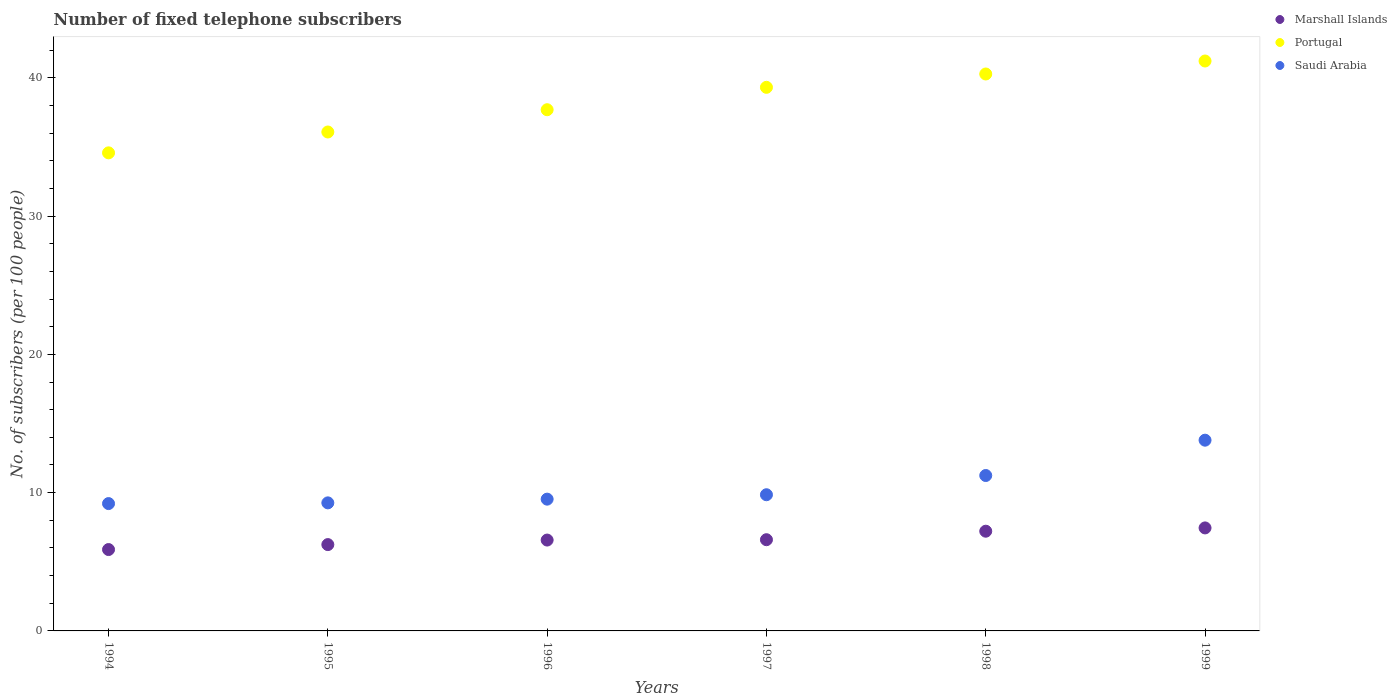What is the number of fixed telephone subscribers in Marshall Islands in 1994?
Give a very brief answer. 5.88. Across all years, what is the maximum number of fixed telephone subscribers in Saudi Arabia?
Your answer should be compact. 13.79. Across all years, what is the minimum number of fixed telephone subscribers in Portugal?
Provide a short and direct response. 34.57. In which year was the number of fixed telephone subscribers in Marshall Islands maximum?
Offer a terse response. 1999. In which year was the number of fixed telephone subscribers in Portugal minimum?
Offer a very short reply. 1994. What is the total number of fixed telephone subscribers in Marshall Islands in the graph?
Ensure brevity in your answer.  39.95. What is the difference between the number of fixed telephone subscribers in Saudi Arabia in 1995 and that in 1998?
Your answer should be very brief. -1.98. What is the difference between the number of fixed telephone subscribers in Saudi Arabia in 1998 and the number of fixed telephone subscribers in Marshall Islands in 1996?
Keep it short and to the point. 4.67. What is the average number of fixed telephone subscribers in Marshall Islands per year?
Provide a short and direct response. 6.66. In the year 1997, what is the difference between the number of fixed telephone subscribers in Saudi Arabia and number of fixed telephone subscribers in Marshall Islands?
Make the answer very short. 3.25. What is the ratio of the number of fixed telephone subscribers in Saudi Arabia in 1994 to that in 1999?
Make the answer very short. 0.67. Is the number of fixed telephone subscribers in Saudi Arabia in 1994 less than that in 1997?
Provide a succinct answer. Yes. What is the difference between the highest and the second highest number of fixed telephone subscribers in Saudi Arabia?
Your answer should be very brief. 2.55. What is the difference between the highest and the lowest number of fixed telephone subscribers in Saudi Arabia?
Your answer should be very brief. 4.58. In how many years, is the number of fixed telephone subscribers in Saudi Arabia greater than the average number of fixed telephone subscribers in Saudi Arabia taken over all years?
Give a very brief answer. 2. Is it the case that in every year, the sum of the number of fixed telephone subscribers in Marshall Islands and number of fixed telephone subscribers in Portugal  is greater than the number of fixed telephone subscribers in Saudi Arabia?
Give a very brief answer. Yes. Does the number of fixed telephone subscribers in Marshall Islands monotonically increase over the years?
Provide a succinct answer. Yes. Is the number of fixed telephone subscribers in Saudi Arabia strictly greater than the number of fixed telephone subscribers in Marshall Islands over the years?
Provide a short and direct response. Yes. Is the number of fixed telephone subscribers in Saudi Arabia strictly less than the number of fixed telephone subscribers in Portugal over the years?
Provide a short and direct response. Yes. What is the difference between two consecutive major ticks on the Y-axis?
Offer a terse response. 10. What is the title of the graph?
Your response must be concise. Number of fixed telephone subscribers. Does "Guinea" appear as one of the legend labels in the graph?
Offer a very short reply. No. What is the label or title of the Y-axis?
Provide a short and direct response. No. of subscribers (per 100 people). What is the No. of subscribers (per 100 people) in Marshall Islands in 1994?
Ensure brevity in your answer.  5.88. What is the No. of subscribers (per 100 people) in Portugal in 1994?
Give a very brief answer. 34.57. What is the No. of subscribers (per 100 people) in Saudi Arabia in 1994?
Provide a succinct answer. 9.21. What is the No. of subscribers (per 100 people) in Marshall Islands in 1995?
Your answer should be very brief. 6.24. What is the No. of subscribers (per 100 people) of Portugal in 1995?
Offer a terse response. 36.08. What is the No. of subscribers (per 100 people) in Saudi Arabia in 1995?
Offer a terse response. 9.26. What is the No. of subscribers (per 100 people) in Marshall Islands in 1996?
Give a very brief answer. 6.57. What is the No. of subscribers (per 100 people) in Portugal in 1996?
Ensure brevity in your answer.  37.69. What is the No. of subscribers (per 100 people) in Saudi Arabia in 1996?
Your response must be concise. 9.53. What is the No. of subscribers (per 100 people) in Marshall Islands in 1997?
Ensure brevity in your answer.  6.6. What is the No. of subscribers (per 100 people) of Portugal in 1997?
Offer a terse response. 39.31. What is the No. of subscribers (per 100 people) in Saudi Arabia in 1997?
Provide a short and direct response. 9.85. What is the No. of subscribers (per 100 people) in Marshall Islands in 1998?
Ensure brevity in your answer.  7.21. What is the No. of subscribers (per 100 people) of Portugal in 1998?
Your answer should be very brief. 40.27. What is the No. of subscribers (per 100 people) in Saudi Arabia in 1998?
Offer a terse response. 11.24. What is the No. of subscribers (per 100 people) of Marshall Islands in 1999?
Ensure brevity in your answer.  7.45. What is the No. of subscribers (per 100 people) of Portugal in 1999?
Keep it short and to the point. 41.21. What is the No. of subscribers (per 100 people) in Saudi Arabia in 1999?
Provide a succinct answer. 13.79. Across all years, what is the maximum No. of subscribers (per 100 people) in Marshall Islands?
Your answer should be compact. 7.45. Across all years, what is the maximum No. of subscribers (per 100 people) in Portugal?
Your answer should be compact. 41.21. Across all years, what is the maximum No. of subscribers (per 100 people) of Saudi Arabia?
Your answer should be compact. 13.79. Across all years, what is the minimum No. of subscribers (per 100 people) in Marshall Islands?
Provide a succinct answer. 5.88. Across all years, what is the minimum No. of subscribers (per 100 people) of Portugal?
Your answer should be compact. 34.57. Across all years, what is the minimum No. of subscribers (per 100 people) of Saudi Arabia?
Give a very brief answer. 9.21. What is the total No. of subscribers (per 100 people) of Marshall Islands in the graph?
Your answer should be compact. 39.95. What is the total No. of subscribers (per 100 people) of Portugal in the graph?
Provide a succinct answer. 229.13. What is the total No. of subscribers (per 100 people) in Saudi Arabia in the graph?
Your response must be concise. 62.88. What is the difference between the No. of subscribers (per 100 people) of Marshall Islands in 1994 and that in 1995?
Offer a terse response. -0.36. What is the difference between the No. of subscribers (per 100 people) of Portugal in 1994 and that in 1995?
Your answer should be very brief. -1.51. What is the difference between the No. of subscribers (per 100 people) of Saudi Arabia in 1994 and that in 1995?
Your answer should be compact. -0.05. What is the difference between the No. of subscribers (per 100 people) of Marshall Islands in 1994 and that in 1996?
Offer a terse response. -0.69. What is the difference between the No. of subscribers (per 100 people) of Portugal in 1994 and that in 1996?
Provide a succinct answer. -3.12. What is the difference between the No. of subscribers (per 100 people) of Saudi Arabia in 1994 and that in 1996?
Offer a very short reply. -0.32. What is the difference between the No. of subscribers (per 100 people) in Marshall Islands in 1994 and that in 1997?
Provide a succinct answer. -0.71. What is the difference between the No. of subscribers (per 100 people) of Portugal in 1994 and that in 1997?
Offer a terse response. -4.74. What is the difference between the No. of subscribers (per 100 people) in Saudi Arabia in 1994 and that in 1997?
Provide a short and direct response. -0.64. What is the difference between the No. of subscribers (per 100 people) of Marshall Islands in 1994 and that in 1998?
Provide a succinct answer. -1.33. What is the difference between the No. of subscribers (per 100 people) in Portugal in 1994 and that in 1998?
Your answer should be compact. -5.7. What is the difference between the No. of subscribers (per 100 people) of Saudi Arabia in 1994 and that in 1998?
Your response must be concise. -2.03. What is the difference between the No. of subscribers (per 100 people) in Marshall Islands in 1994 and that in 1999?
Keep it short and to the point. -1.56. What is the difference between the No. of subscribers (per 100 people) in Portugal in 1994 and that in 1999?
Ensure brevity in your answer.  -6.64. What is the difference between the No. of subscribers (per 100 people) in Saudi Arabia in 1994 and that in 1999?
Give a very brief answer. -4.58. What is the difference between the No. of subscribers (per 100 people) in Marshall Islands in 1995 and that in 1996?
Offer a very short reply. -0.33. What is the difference between the No. of subscribers (per 100 people) in Portugal in 1995 and that in 1996?
Your answer should be compact. -1.61. What is the difference between the No. of subscribers (per 100 people) of Saudi Arabia in 1995 and that in 1996?
Offer a very short reply. -0.27. What is the difference between the No. of subscribers (per 100 people) of Marshall Islands in 1995 and that in 1997?
Give a very brief answer. -0.35. What is the difference between the No. of subscribers (per 100 people) of Portugal in 1995 and that in 1997?
Make the answer very short. -3.23. What is the difference between the No. of subscribers (per 100 people) in Saudi Arabia in 1995 and that in 1997?
Provide a succinct answer. -0.59. What is the difference between the No. of subscribers (per 100 people) of Marshall Islands in 1995 and that in 1998?
Offer a very short reply. -0.97. What is the difference between the No. of subscribers (per 100 people) in Portugal in 1995 and that in 1998?
Give a very brief answer. -4.19. What is the difference between the No. of subscribers (per 100 people) in Saudi Arabia in 1995 and that in 1998?
Provide a succinct answer. -1.98. What is the difference between the No. of subscribers (per 100 people) in Marshall Islands in 1995 and that in 1999?
Offer a terse response. -1.21. What is the difference between the No. of subscribers (per 100 people) in Portugal in 1995 and that in 1999?
Keep it short and to the point. -5.13. What is the difference between the No. of subscribers (per 100 people) in Saudi Arabia in 1995 and that in 1999?
Offer a terse response. -4.53. What is the difference between the No. of subscribers (per 100 people) in Marshall Islands in 1996 and that in 1997?
Give a very brief answer. -0.03. What is the difference between the No. of subscribers (per 100 people) of Portugal in 1996 and that in 1997?
Your response must be concise. -1.62. What is the difference between the No. of subscribers (per 100 people) of Saudi Arabia in 1996 and that in 1997?
Offer a terse response. -0.32. What is the difference between the No. of subscribers (per 100 people) of Marshall Islands in 1996 and that in 1998?
Your answer should be very brief. -0.64. What is the difference between the No. of subscribers (per 100 people) in Portugal in 1996 and that in 1998?
Make the answer very short. -2.58. What is the difference between the No. of subscribers (per 100 people) in Saudi Arabia in 1996 and that in 1998?
Give a very brief answer. -1.71. What is the difference between the No. of subscribers (per 100 people) in Marshall Islands in 1996 and that in 1999?
Your answer should be compact. -0.88. What is the difference between the No. of subscribers (per 100 people) in Portugal in 1996 and that in 1999?
Offer a very short reply. -3.52. What is the difference between the No. of subscribers (per 100 people) in Saudi Arabia in 1996 and that in 1999?
Offer a very short reply. -4.26. What is the difference between the No. of subscribers (per 100 people) of Marshall Islands in 1997 and that in 1998?
Provide a succinct answer. -0.61. What is the difference between the No. of subscribers (per 100 people) in Portugal in 1997 and that in 1998?
Provide a succinct answer. -0.96. What is the difference between the No. of subscribers (per 100 people) of Saudi Arabia in 1997 and that in 1998?
Your answer should be compact. -1.39. What is the difference between the No. of subscribers (per 100 people) in Marshall Islands in 1997 and that in 1999?
Ensure brevity in your answer.  -0.85. What is the difference between the No. of subscribers (per 100 people) in Portugal in 1997 and that in 1999?
Provide a short and direct response. -1.9. What is the difference between the No. of subscribers (per 100 people) in Saudi Arabia in 1997 and that in 1999?
Your response must be concise. -3.94. What is the difference between the No. of subscribers (per 100 people) in Marshall Islands in 1998 and that in 1999?
Your answer should be very brief. -0.24. What is the difference between the No. of subscribers (per 100 people) of Portugal in 1998 and that in 1999?
Make the answer very short. -0.94. What is the difference between the No. of subscribers (per 100 people) of Saudi Arabia in 1998 and that in 1999?
Give a very brief answer. -2.55. What is the difference between the No. of subscribers (per 100 people) of Marshall Islands in 1994 and the No. of subscribers (per 100 people) of Portugal in 1995?
Your answer should be very brief. -30.19. What is the difference between the No. of subscribers (per 100 people) in Marshall Islands in 1994 and the No. of subscribers (per 100 people) in Saudi Arabia in 1995?
Offer a very short reply. -3.38. What is the difference between the No. of subscribers (per 100 people) of Portugal in 1994 and the No. of subscribers (per 100 people) of Saudi Arabia in 1995?
Offer a terse response. 25.31. What is the difference between the No. of subscribers (per 100 people) of Marshall Islands in 1994 and the No. of subscribers (per 100 people) of Portugal in 1996?
Provide a short and direct response. -31.8. What is the difference between the No. of subscribers (per 100 people) of Marshall Islands in 1994 and the No. of subscribers (per 100 people) of Saudi Arabia in 1996?
Make the answer very short. -3.64. What is the difference between the No. of subscribers (per 100 people) in Portugal in 1994 and the No. of subscribers (per 100 people) in Saudi Arabia in 1996?
Ensure brevity in your answer.  25.04. What is the difference between the No. of subscribers (per 100 people) in Marshall Islands in 1994 and the No. of subscribers (per 100 people) in Portugal in 1997?
Your answer should be compact. -33.42. What is the difference between the No. of subscribers (per 100 people) of Marshall Islands in 1994 and the No. of subscribers (per 100 people) of Saudi Arabia in 1997?
Provide a succinct answer. -3.96. What is the difference between the No. of subscribers (per 100 people) in Portugal in 1994 and the No. of subscribers (per 100 people) in Saudi Arabia in 1997?
Provide a short and direct response. 24.72. What is the difference between the No. of subscribers (per 100 people) of Marshall Islands in 1994 and the No. of subscribers (per 100 people) of Portugal in 1998?
Your answer should be very brief. -34.39. What is the difference between the No. of subscribers (per 100 people) in Marshall Islands in 1994 and the No. of subscribers (per 100 people) in Saudi Arabia in 1998?
Your answer should be compact. -5.35. What is the difference between the No. of subscribers (per 100 people) of Portugal in 1994 and the No. of subscribers (per 100 people) of Saudi Arabia in 1998?
Make the answer very short. 23.33. What is the difference between the No. of subscribers (per 100 people) in Marshall Islands in 1994 and the No. of subscribers (per 100 people) in Portugal in 1999?
Make the answer very short. -35.33. What is the difference between the No. of subscribers (per 100 people) in Marshall Islands in 1994 and the No. of subscribers (per 100 people) in Saudi Arabia in 1999?
Provide a short and direct response. -7.91. What is the difference between the No. of subscribers (per 100 people) in Portugal in 1994 and the No. of subscribers (per 100 people) in Saudi Arabia in 1999?
Provide a succinct answer. 20.78. What is the difference between the No. of subscribers (per 100 people) in Marshall Islands in 1995 and the No. of subscribers (per 100 people) in Portugal in 1996?
Make the answer very short. -31.45. What is the difference between the No. of subscribers (per 100 people) in Marshall Islands in 1995 and the No. of subscribers (per 100 people) in Saudi Arabia in 1996?
Your answer should be compact. -3.29. What is the difference between the No. of subscribers (per 100 people) of Portugal in 1995 and the No. of subscribers (per 100 people) of Saudi Arabia in 1996?
Ensure brevity in your answer.  26.55. What is the difference between the No. of subscribers (per 100 people) in Marshall Islands in 1995 and the No. of subscribers (per 100 people) in Portugal in 1997?
Keep it short and to the point. -33.07. What is the difference between the No. of subscribers (per 100 people) of Marshall Islands in 1995 and the No. of subscribers (per 100 people) of Saudi Arabia in 1997?
Ensure brevity in your answer.  -3.6. What is the difference between the No. of subscribers (per 100 people) of Portugal in 1995 and the No. of subscribers (per 100 people) of Saudi Arabia in 1997?
Provide a short and direct response. 26.23. What is the difference between the No. of subscribers (per 100 people) of Marshall Islands in 1995 and the No. of subscribers (per 100 people) of Portugal in 1998?
Keep it short and to the point. -34.03. What is the difference between the No. of subscribers (per 100 people) of Marshall Islands in 1995 and the No. of subscribers (per 100 people) of Saudi Arabia in 1998?
Offer a very short reply. -5. What is the difference between the No. of subscribers (per 100 people) of Portugal in 1995 and the No. of subscribers (per 100 people) of Saudi Arabia in 1998?
Keep it short and to the point. 24.84. What is the difference between the No. of subscribers (per 100 people) of Marshall Islands in 1995 and the No. of subscribers (per 100 people) of Portugal in 1999?
Keep it short and to the point. -34.97. What is the difference between the No. of subscribers (per 100 people) in Marshall Islands in 1995 and the No. of subscribers (per 100 people) in Saudi Arabia in 1999?
Provide a short and direct response. -7.55. What is the difference between the No. of subscribers (per 100 people) of Portugal in 1995 and the No. of subscribers (per 100 people) of Saudi Arabia in 1999?
Ensure brevity in your answer.  22.29. What is the difference between the No. of subscribers (per 100 people) in Marshall Islands in 1996 and the No. of subscribers (per 100 people) in Portugal in 1997?
Make the answer very short. -32.74. What is the difference between the No. of subscribers (per 100 people) in Marshall Islands in 1996 and the No. of subscribers (per 100 people) in Saudi Arabia in 1997?
Your answer should be very brief. -3.28. What is the difference between the No. of subscribers (per 100 people) of Portugal in 1996 and the No. of subscribers (per 100 people) of Saudi Arabia in 1997?
Offer a terse response. 27.84. What is the difference between the No. of subscribers (per 100 people) of Marshall Islands in 1996 and the No. of subscribers (per 100 people) of Portugal in 1998?
Keep it short and to the point. -33.7. What is the difference between the No. of subscribers (per 100 people) in Marshall Islands in 1996 and the No. of subscribers (per 100 people) in Saudi Arabia in 1998?
Give a very brief answer. -4.67. What is the difference between the No. of subscribers (per 100 people) in Portugal in 1996 and the No. of subscribers (per 100 people) in Saudi Arabia in 1998?
Your answer should be very brief. 26.45. What is the difference between the No. of subscribers (per 100 people) of Marshall Islands in 1996 and the No. of subscribers (per 100 people) of Portugal in 1999?
Your answer should be very brief. -34.64. What is the difference between the No. of subscribers (per 100 people) in Marshall Islands in 1996 and the No. of subscribers (per 100 people) in Saudi Arabia in 1999?
Make the answer very short. -7.22. What is the difference between the No. of subscribers (per 100 people) in Portugal in 1996 and the No. of subscribers (per 100 people) in Saudi Arabia in 1999?
Give a very brief answer. 23.9. What is the difference between the No. of subscribers (per 100 people) of Marshall Islands in 1997 and the No. of subscribers (per 100 people) of Portugal in 1998?
Provide a short and direct response. -33.68. What is the difference between the No. of subscribers (per 100 people) in Marshall Islands in 1997 and the No. of subscribers (per 100 people) in Saudi Arabia in 1998?
Your response must be concise. -4.64. What is the difference between the No. of subscribers (per 100 people) of Portugal in 1997 and the No. of subscribers (per 100 people) of Saudi Arabia in 1998?
Offer a very short reply. 28.07. What is the difference between the No. of subscribers (per 100 people) of Marshall Islands in 1997 and the No. of subscribers (per 100 people) of Portugal in 1999?
Give a very brief answer. -34.62. What is the difference between the No. of subscribers (per 100 people) in Marshall Islands in 1997 and the No. of subscribers (per 100 people) in Saudi Arabia in 1999?
Make the answer very short. -7.2. What is the difference between the No. of subscribers (per 100 people) of Portugal in 1997 and the No. of subscribers (per 100 people) of Saudi Arabia in 1999?
Provide a short and direct response. 25.52. What is the difference between the No. of subscribers (per 100 people) of Marshall Islands in 1998 and the No. of subscribers (per 100 people) of Portugal in 1999?
Keep it short and to the point. -34. What is the difference between the No. of subscribers (per 100 people) of Marshall Islands in 1998 and the No. of subscribers (per 100 people) of Saudi Arabia in 1999?
Ensure brevity in your answer.  -6.58. What is the difference between the No. of subscribers (per 100 people) in Portugal in 1998 and the No. of subscribers (per 100 people) in Saudi Arabia in 1999?
Your answer should be compact. 26.48. What is the average No. of subscribers (per 100 people) in Marshall Islands per year?
Keep it short and to the point. 6.66. What is the average No. of subscribers (per 100 people) of Portugal per year?
Keep it short and to the point. 38.19. What is the average No. of subscribers (per 100 people) of Saudi Arabia per year?
Keep it short and to the point. 10.48. In the year 1994, what is the difference between the No. of subscribers (per 100 people) in Marshall Islands and No. of subscribers (per 100 people) in Portugal?
Offer a very short reply. -28.69. In the year 1994, what is the difference between the No. of subscribers (per 100 people) in Marshall Islands and No. of subscribers (per 100 people) in Saudi Arabia?
Your response must be concise. -3.32. In the year 1994, what is the difference between the No. of subscribers (per 100 people) in Portugal and No. of subscribers (per 100 people) in Saudi Arabia?
Offer a very short reply. 25.36. In the year 1995, what is the difference between the No. of subscribers (per 100 people) in Marshall Islands and No. of subscribers (per 100 people) in Portugal?
Offer a very short reply. -29.84. In the year 1995, what is the difference between the No. of subscribers (per 100 people) in Marshall Islands and No. of subscribers (per 100 people) in Saudi Arabia?
Offer a very short reply. -3.02. In the year 1995, what is the difference between the No. of subscribers (per 100 people) in Portugal and No. of subscribers (per 100 people) in Saudi Arabia?
Offer a terse response. 26.82. In the year 1996, what is the difference between the No. of subscribers (per 100 people) in Marshall Islands and No. of subscribers (per 100 people) in Portugal?
Your answer should be compact. -31.12. In the year 1996, what is the difference between the No. of subscribers (per 100 people) in Marshall Islands and No. of subscribers (per 100 people) in Saudi Arabia?
Keep it short and to the point. -2.96. In the year 1996, what is the difference between the No. of subscribers (per 100 people) in Portugal and No. of subscribers (per 100 people) in Saudi Arabia?
Give a very brief answer. 28.16. In the year 1997, what is the difference between the No. of subscribers (per 100 people) in Marshall Islands and No. of subscribers (per 100 people) in Portugal?
Provide a succinct answer. -32.71. In the year 1997, what is the difference between the No. of subscribers (per 100 people) of Marshall Islands and No. of subscribers (per 100 people) of Saudi Arabia?
Keep it short and to the point. -3.25. In the year 1997, what is the difference between the No. of subscribers (per 100 people) of Portugal and No. of subscribers (per 100 people) of Saudi Arabia?
Give a very brief answer. 29.46. In the year 1998, what is the difference between the No. of subscribers (per 100 people) of Marshall Islands and No. of subscribers (per 100 people) of Portugal?
Your answer should be very brief. -33.06. In the year 1998, what is the difference between the No. of subscribers (per 100 people) of Marshall Islands and No. of subscribers (per 100 people) of Saudi Arabia?
Your answer should be very brief. -4.03. In the year 1998, what is the difference between the No. of subscribers (per 100 people) of Portugal and No. of subscribers (per 100 people) of Saudi Arabia?
Ensure brevity in your answer.  29.03. In the year 1999, what is the difference between the No. of subscribers (per 100 people) in Marshall Islands and No. of subscribers (per 100 people) in Portugal?
Offer a terse response. -33.76. In the year 1999, what is the difference between the No. of subscribers (per 100 people) in Marshall Islands and No. of subscribers (per 100 people) in Saudi Arabia?
Provide a short and direct response. -6.34. In the year 1999, what is the difference between the No. of subscribers (per 100 people) of Portugal and No. of subscribers (per 100 people) of Saudi Arabia?
Ensure brevity in your answer.  27.42. What is the ratio of the No. of subscribers (per 100 people) in Marshall Islands in 1994 to that in 1995?
Your response must be concise. 0.94. What is the ratio of the No. of subscribers (per 100 people) of Portugal in 1994 to that in 1995?
Provide a short and direct response. 0.96. What is the ratio of the No. of subscribers (per 100 people) in Marshall Islands in 1994 to that in 1996?
Your response must be concise. 0.9. What is the ratio of the No. of subscribers (per 100 people) of Portugal in 1994 to that in 1996?
Your response must be concise. 0.92. What is the ratio of the No. of subscribers (per 100 people) of Saudi Arabia in 1994 to that in 1996?
Your response must be concise. 0.97. What is the ratio of the No. of subscribers (per 100 people) in Marshall Islands in 1994 to that in 1997?
Offer a terse response. 0.89. What is the ratio of the No. of subscribers (per 100 people) of Portugal in 1994 to that in 1997?
Ensure brevity in your answer.  0.88. What is the ratio of the No. of subscribers (per 100 people) of Saudi Arabia in 1994 to that in 1997?
Keep it short and to the point. 0.94. What is the ratio of the No. of subscribers (per 100 people) of Marshall Islands in 1994 to that in 1998?
Provide a succinct answer. 0.82. What is the ratio of the No. of subscribers (per 100 people) of Portugal in 1994 to that in 1998?
Provide a succinct answer. 0.86. What is the ratio of the No. of subscribers (per 100 people) in Saudi Arabia in 1994 to that in 1998?
Your response must be concise. 0.82. What is the ratio of the No. of subscribers (per 100 people) of Marshall Islands in 1994 to that in 1999?
Provide a succinct answer. 0.79. What is the ratio of the No. of subscribers (per 100 people) of Portugal in 1994 to that in 1999?
Make the answer very short. 0.84. What is the ratio of the No. of subscribers (per 100 people) in Saudi Arabia in 1994 to that in 1999?
Make the answer very short. 0.67. What is the ratio of the No. of subscribers (per 100 people) of Marshall Islands in 1995 to that in 1996?
Provide a short and direct response. 0.95. What is the ratio of the No. of subscribers (per 100 people) of Portugal in 1995 to that in 1996?
Provide a short and direct response. 0.96. What is the ratio of the No. of subscribers (per 100 people) of Saudi Arabia in 1995 to that in 1996?
Your answer should be compact. 0.97. What is the ratio of the No. of subscribers (per 100 people) of Marshall Islands in 1995 to that in 1997?
Ensure brevity in your answer.  0.95. What is the ratio of the No. of subscribers (per 100 people) in Portugal in 1995 to that in 1997?
Your answer should be very brief. 0.92. What is the ratio of the No. of subscribers (per 100 people) in Saudi Arabia in 1995 to that in 1997?
Your response must be concise. 0.94. What is the ratio of the No. of subscribers (per 100 people) in Marshall Islands in 1995 to that in 1998?
Ensure brevity in your answer.  0.87. What is the ratio of the No. of subscribers (per 100 people) in Portugal in 1995 to that in 1998?
Ensure brevity in your answer.  0.9. What is the ratio of the No. of subscribers (per 100 people) in Saudi Arabia in 1995 to that in 1998?
Give a very brief answer. 0.82. What is the ratio of the No. of subscribers (per 100 people) in Marshall Islands in 1995 to that in 1999?
Your answer should be very brief. 0.84. What is the ratio of the No. of subscribers (per 100 people) in Portugal in 1995 to that in 1999?
Keep it short and to the point. 0.88. What is the ratio of the No. of subscribers (per 100 people) of Saudi Arabia in 1995 to that in 1999?
Offer a terse response. 0.67. What is the ratio of the No. of subscribers (per 100 people) of Portugal in 1996 to that in 1997?
Your answer should be very brief. 0.96. What is the ratio of the No. of subscribers (per 100 people) in Saudi Arabia in 1996 to that in 1997?
Your response must be concise. 0.97. What is the ratio of the No. of subscribers (per 100 people) in Marshall Islands in 1996 to that in 1998?
Make the answer very short. 0.91. What is the ratio of the No. of subscribers (per 100 people) of Portugal in 1996 to that in 1998?
Provide a succinct answer. 0.94. What is the ratio of the No. of subscribers (per 100 people) in Saudi Arabia in 1996 to that in 1998?
Offer a terse response. 0.85. What is the ratio of the No. of subscribers (per 100 people) of Marshall Islands in 1996 to that in 1999?
Offer a terse response. 0.88. What is the ratio of the No. of subscribers (per 100 people) of Portugal in 1996 to that in 1999?
Provide a short and direct response. 0.91. What is the ratio of the No. of subscribers (per 100 people) in Saudi Arabia in 1996 to that in 1999?
Offer a very short reply. 0.69. What is the ratio of the No. of subscribers (per 100 people) in Marshall Islands in 1997 to that in 1998?
Your response must be concise. 0.91. What is the ratio of the No. of subscribers (per 100 people) of Portugal in 1997 to that in 1998?
Make the answer very short. 0.98. What is the ratio of the No. of subscribers (per 100 people) in Saudi Arabia in 1997 to that in 1998?
Offer a terse response. 0.88. What is the ratio of the No. of subscribers (per 100 people) in Marshall Islands in 1997 to that in 1999?
Your answer should be very brief. 0.89. What is the ratio of the No. of subscribers (per 100 people) of Portugal in 1997 to that in 1999?
Your answer should be very brief. 0.95. What is the ratio of the No. of subscribers (per 100 people) of Saudi Arabia in 1997 to that in 1999?
Provide a succinct answer. 0.71. What is the ratio of the No. of subscribers (per 100 people) in Marshall Islands in 1998 to that in 1999?
Offer a very short reply. 0.97. What is the ratio of the No. of subscribers (per 100 people) in Portugal in 1998 to that in 1999?
Your answer should be compact. 0.98. What is the ratio of the No. of subscribers (per 100 people) of Saudi Arabia in 1998 to that in 1999?
Provide a short and direct response. 0.81. What is the difference between the highest and the second highest No. of subscribers (per 100 people) in Marshall Islands?
Your answer should be very brief. 0.24. What is the difference between the highest and the second highest No. of subscribers (per 100 people) in Portugal?
Offer a terse response. 0.94. What is the difference between the highest and the second highest No. of subscribers (per 100 people) of Saudi Arabia?
Keep it short and to the point. 2.55. What is the difference between the highest and the lowest No. of subscribers (per 100 people) of Marshall Islands?
Offer a very short reply. 1.56. What is the difference between the highest and the lowest No. of subscribers (per 100 people) of Portugal?
Provide a short and direct response. 6.64. What is the difference between the highest and the lowest No. of subscribers (per 100 people) in Saudi Arabia?
Give a very brief answer. 4.58. 